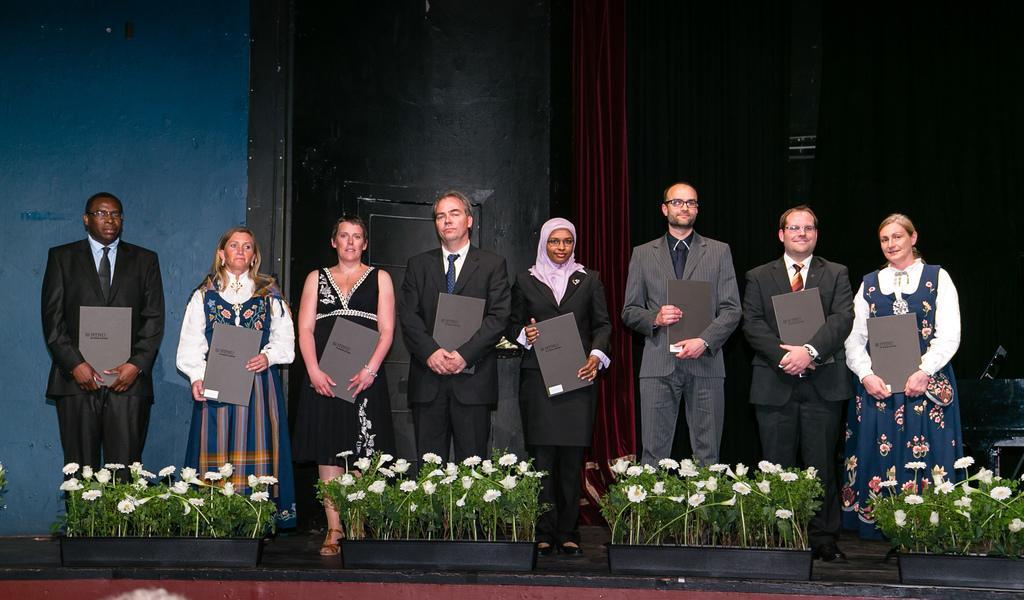Please provide a concise description of this image. In this picture there are group of people standing on the stage and holding the books. At the back there is a curtain and wall. On the right side of the image there is a table. In the foreground there are white color flowers on the plants and there are plants in the pots. 